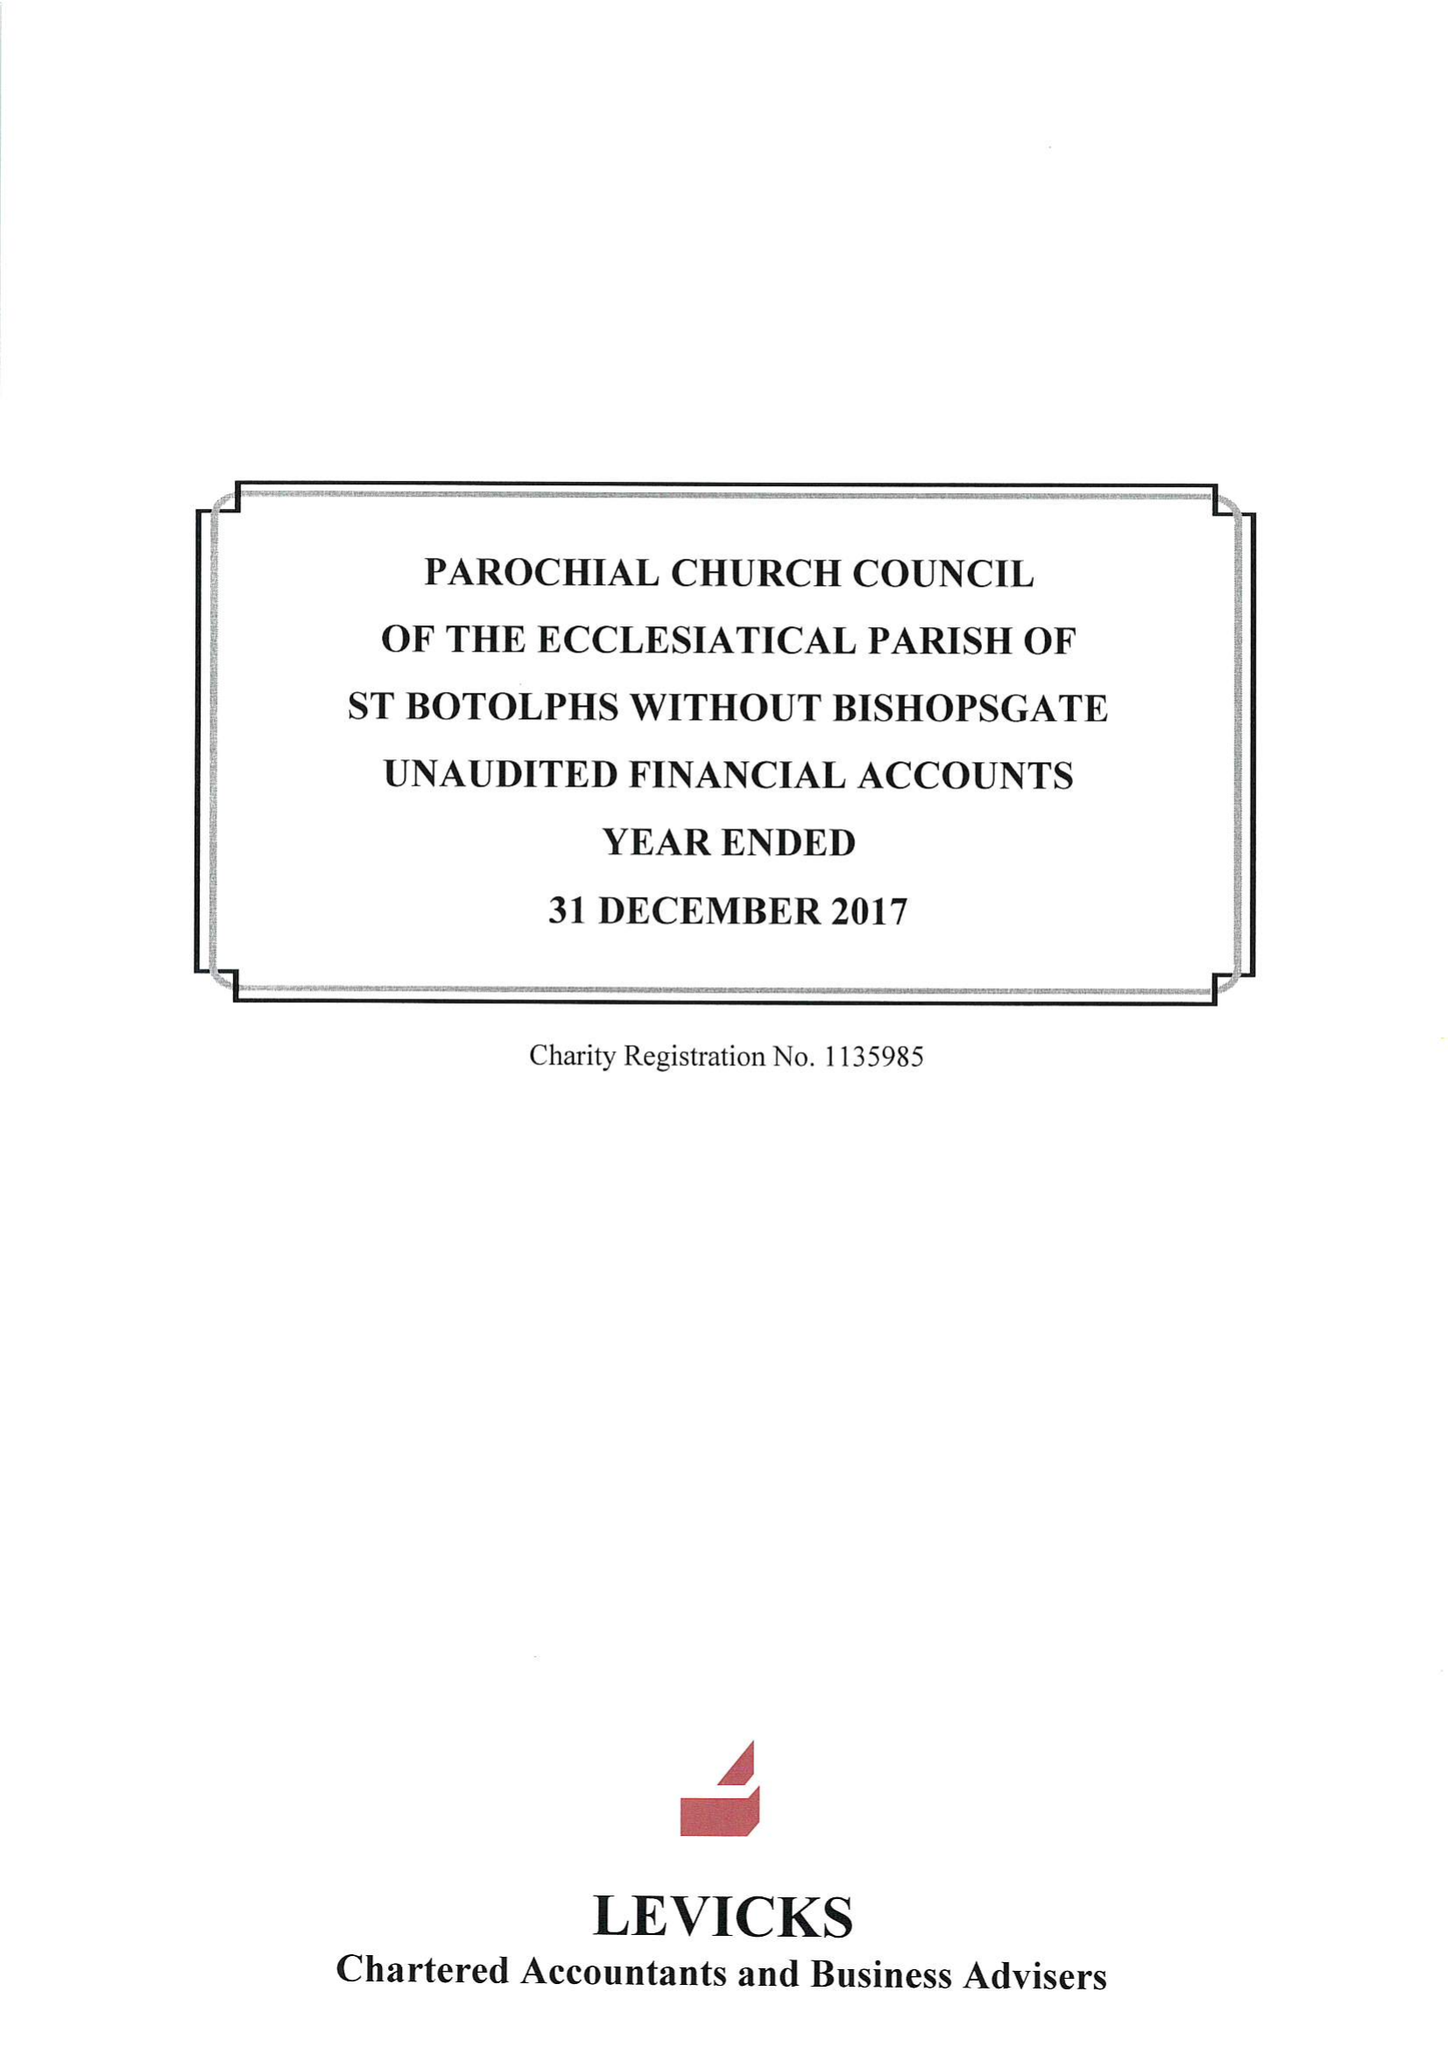What is the value for the income_annually_in_british_pounds?
Answer the question using a single word or phrase. 354590.00 